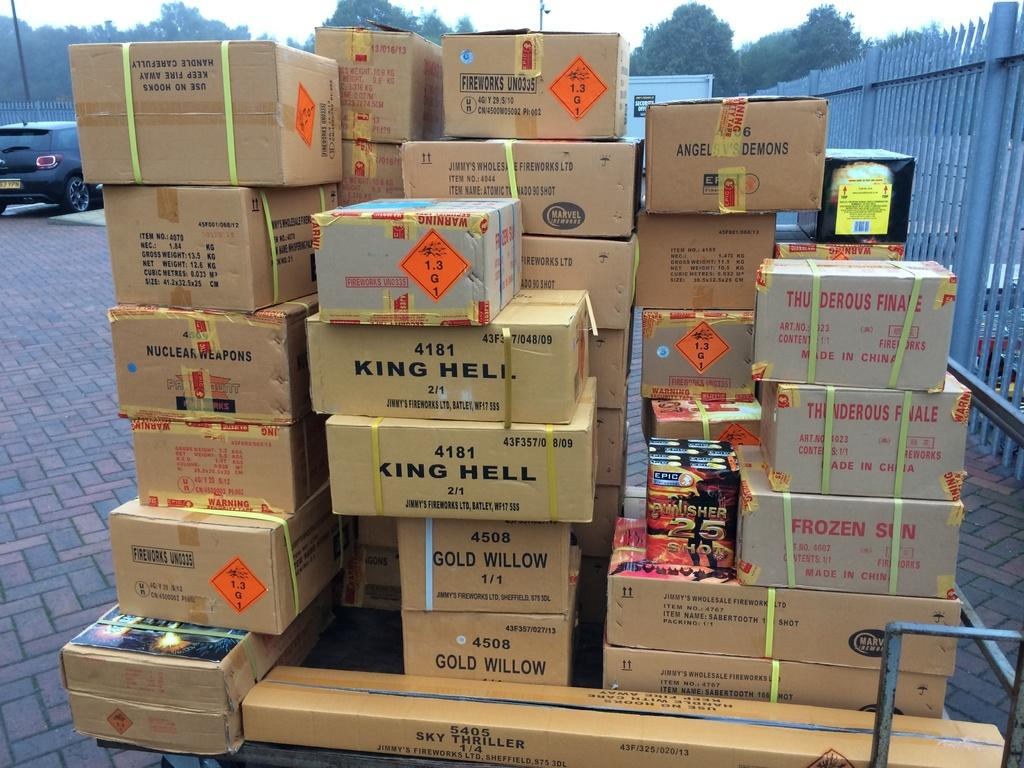<image>
Write a terse but informative summary of the picture. Large pallet of fireworks including King Hell and Gold Willow 